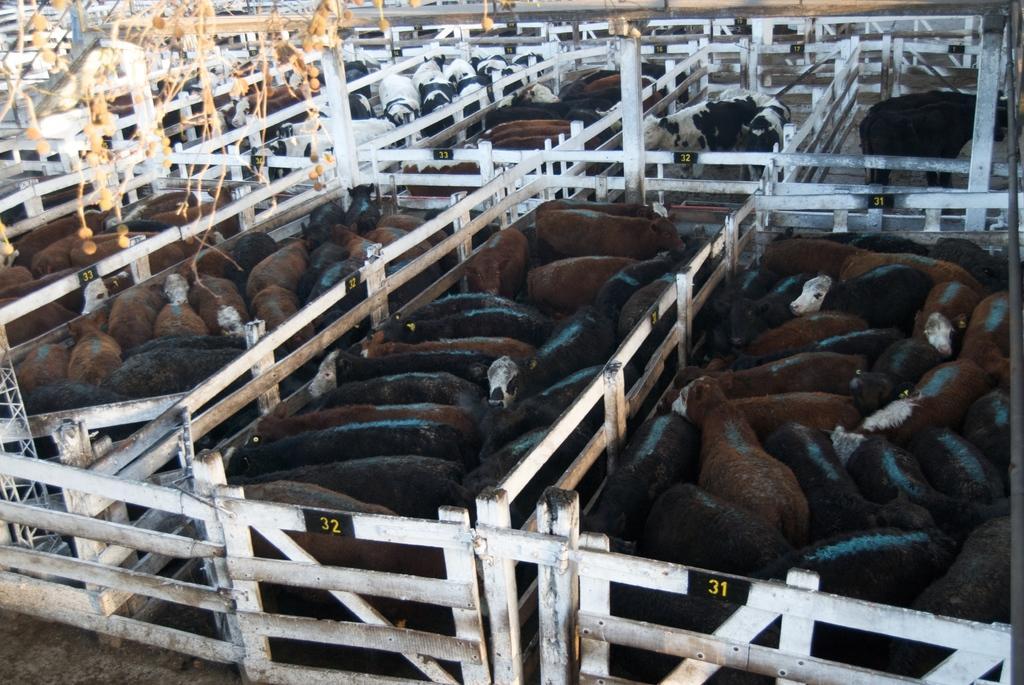Describe this image in one or two sentences. In this image there is a dairy farm. There are cabins in the image. They are separated with the railing. There are boards on the railing. Inside them there are cattle. At the top there is a bridge. 